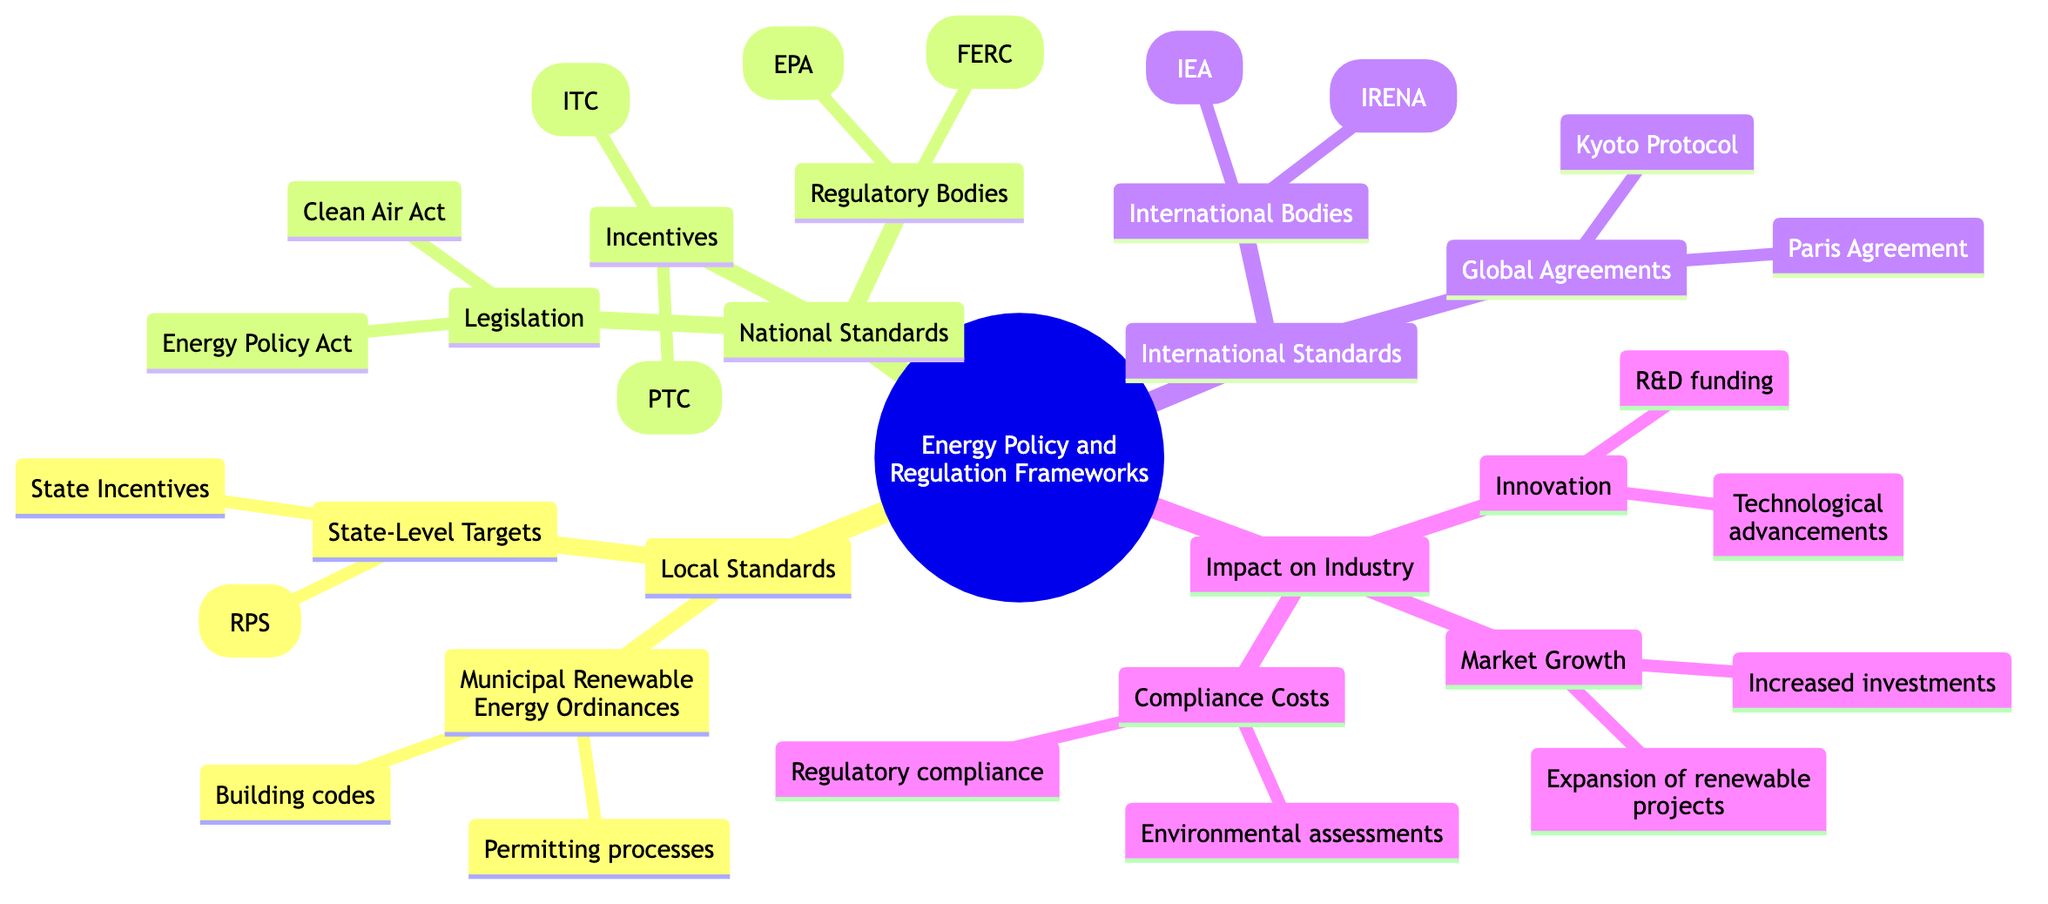What are the local standards mentioned in the diagram? The diagram lists two categories under Local Standards: Municipal Renewable Energy Ordinances and State-Level Targets. These categories collectively represent the various local compliance and target-setting mechanisms for renewable energy policy.
Answer: Municipal Renewable Energy Ordinances, State-Level Targets How many legislative acts are shown under National Standards? The diagram specifies two legislative acts under National Standards: Energy Policy Act and Clean Air Act. By counting these, we find that there are two acts directly mentioned.
Answer: 2 What is one of the incentives listed under National Standards? In the diagram, two categories of incentives are listed. Under National Standards, one of the mentioned incentives is the Investment Tax Credit (ITC), which serves as a financial benefit to encourage renewable energy investments.
Answer: Investment Tax Credit (ITC) Which international agreement is listed under International Standards? The diagram highlights two global agreements under International Standards: Paris Agreement and Kyoto Protocol. The question asks for one of them, so any of the identified agreements would suffice as an acceptable answer.
Answer: Paris Agreement What impact category focuses on financial implications for companies? The diagram indicates three categories of impact on the industry; the one that specifically addresses the financial implications of compliance is Compliance Costs, which would cover aspects like regulatory compliance and environmental assessments.
Answer: Compliance Costs Which regulatory body is responsible for energy regulation in the U.S.? The Federal Energy Regulatory Commission (FERC) is mentioned under National Standards as a key regulatory body responsible for overseeing energy regulations in the United States, as per the diagram's data.
Answer: Federal Energy Regulatory Commission (FERC) Which aspect of impact emphasizes advancements? The diagram is structured to show several impact categories, with Innovation specifically focusing on advancements in renewable energy. This part of the framework discusses R&D funding and technological advancements relevant to the field.
Answer: Innovation How many international bodies are referenced in the diagram? The diagram enumerates two international bodies under International Standards: International Renewable Energy Agency (IRENA) and International Energy Agency (IEA). Thus, the total count of these entities amounts to two.
Answer: 2 What is one of the state-level targets mentioned in the diagram? The diagram outlines a specific target known as Renewable Portfolio Standards (RPS) under the State-Level Targets category. This represents a policy designed to encourage utility companies to procure a certain percentage of their energy from renewable sources.
Answer: Renewable Portfolio Standards (RPS) 